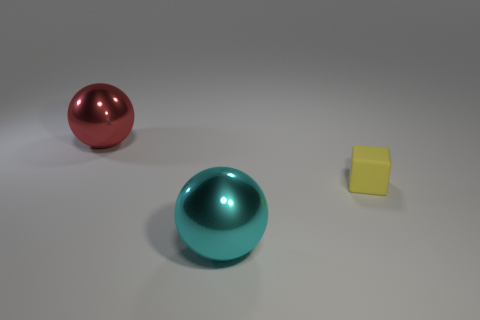Add 3 tiny red cylinders. How many objects exist? 6 Subtract all balls. How many objects are left? 1 Add 3 green metal balls. How many green metal balls exist? 3 Subtract 0 gray spheres. How many objects are left? 3 Subtract all tiny green metallic cylinders. Subtract all big metallic things. How many objects are left? 1 Add 3 shiny objects. How many shiny objects are left? 5 